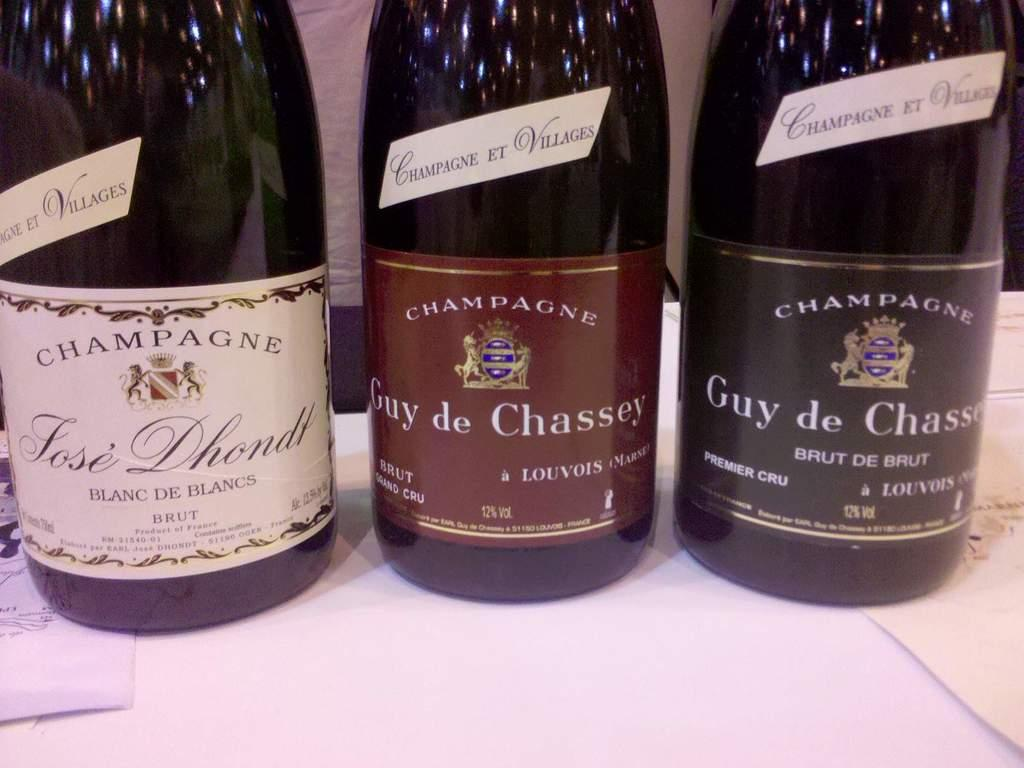<image>
Provide a brief description of the given image. Three bottles of Champagne sit side by side. 